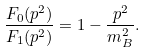Convert formula to latex. <formula><loc_0><loc_0><loc_500><loc_500>\frac { F _ { 0 } ( p ^ { 2 } ) } { F _ { 1 } ( p ^ { 2 } ) } = 1 - \frac { p ^ { 2 } } { m _ { B } ^ { 2 } } .</formula> 